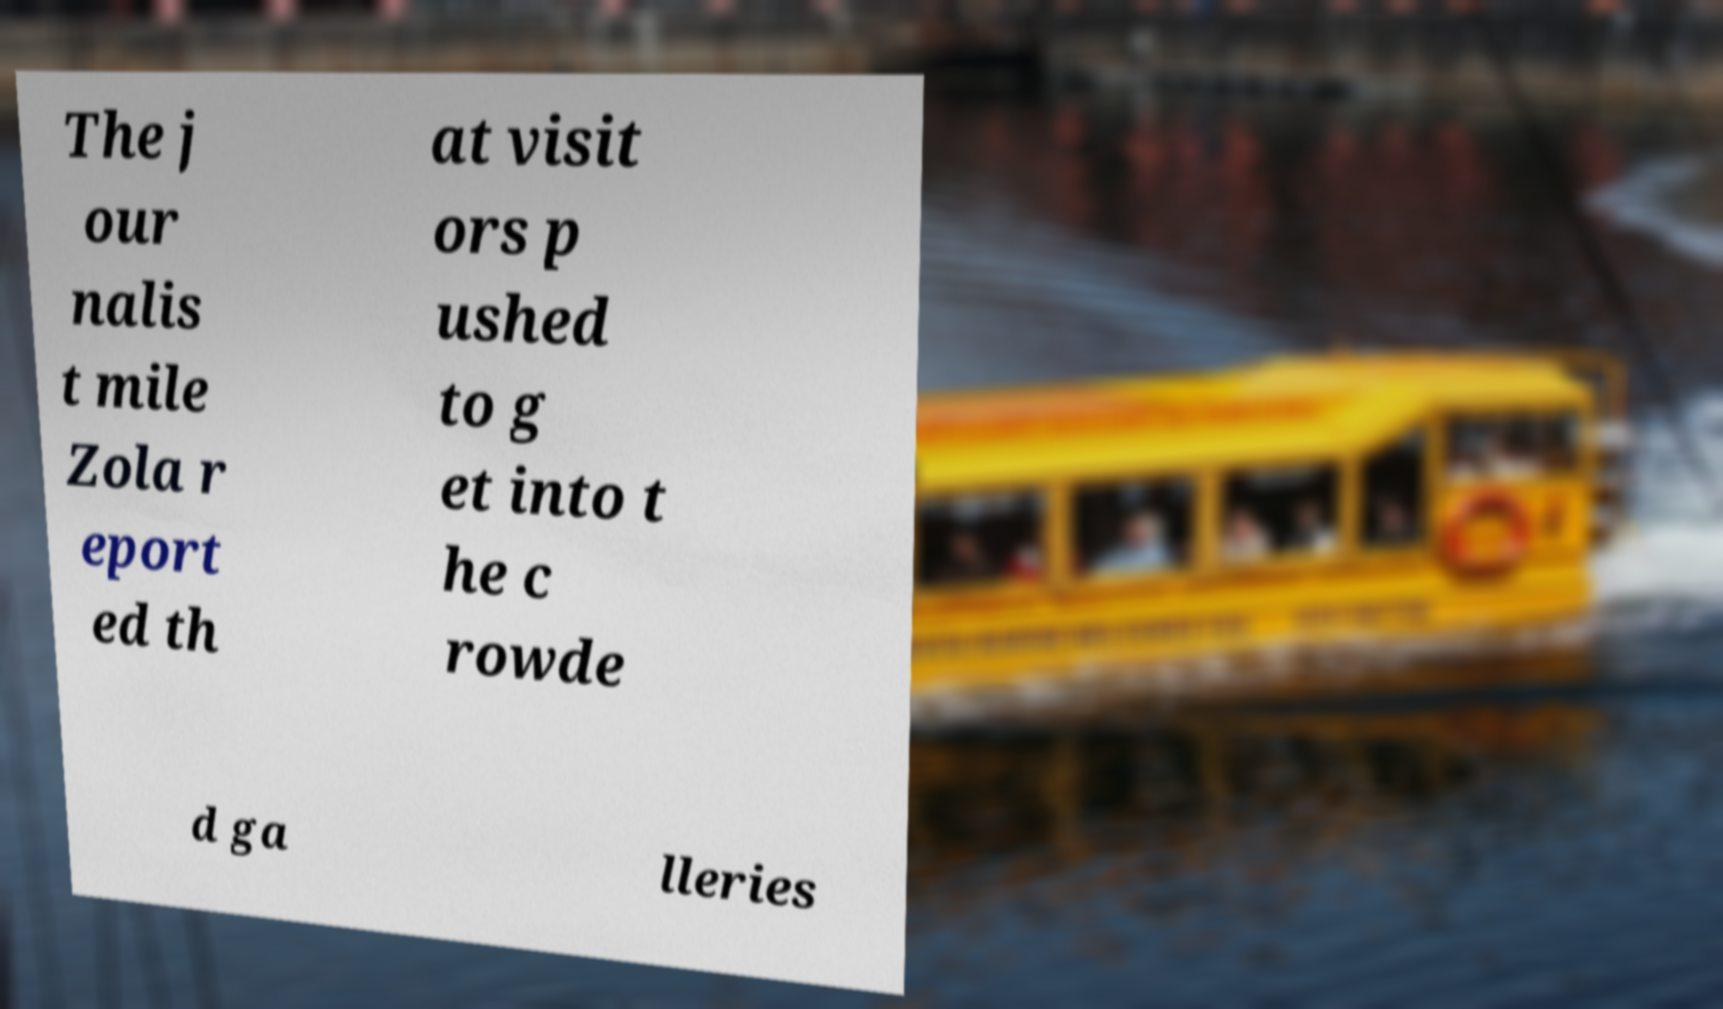Can you accurately transcribe the text from the provided image for me? The j our nalis t mile Zola r eport ed th at visit ors p ushed to g et into t he c rowde d ga lleries 